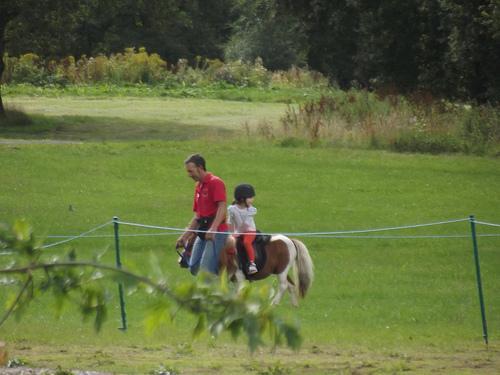How many horses in this picture?
Give a very brief answer. 1. How many people in this picture?
Give a very brief answer. 2. 